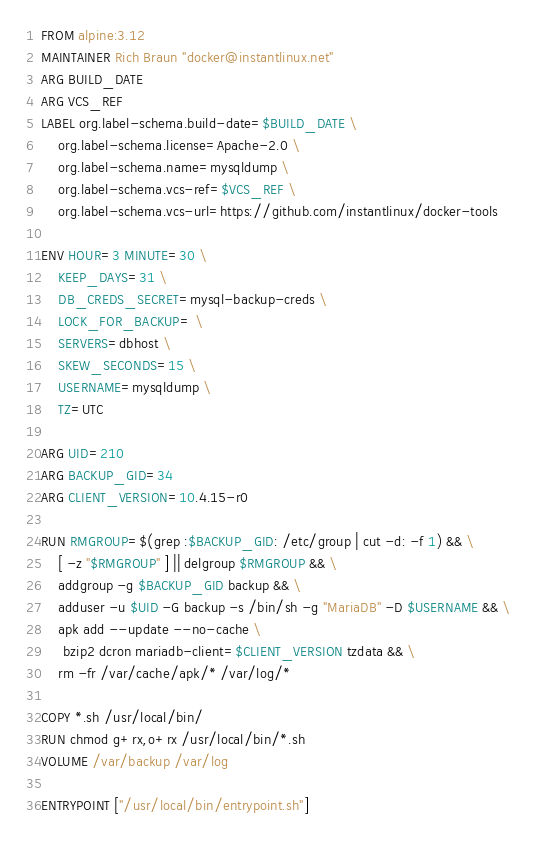<code> <loc_0><loc_0><loc_500><loc_500><_Dockerfile_>FROM alpine:3.12
MAINTAINER Rich Braun "docker@instantlinux.net"
ARG BUILD_DATE
ARG VCS_REF
LABEL org.label-schema.build-date=$BUILD_DATE \
    org.label-schema.license=Apache-2.0 \
    org.label-schema.name=mysqldump \
    org.label-schema.vcs-ref=$VCS_REF \
    org.label-schema.vcs-url=https://github.com/instantlinux/docker-tools

ENV HOUR=3 MINUTE=30 \
    KEEP_DAYS=31 \
    DB_CREDS_SECRET=mysql-backup-creds \
    LOCK_FOR_BACKUP= \
    SERVERS=dbhost \
    SKEW_SECONDS=15 \
    USERNAME=mysqldump \
    TZ=UTC

ARG UID=210
ARG BACKUP_GID=34
ARG CLIENT_VERSION=10.4.15-r0

RUN RMGROUP=$(grep :$BACKUP_GID: /etc/group | cut -d: -f 1) && \
    [ -z "$RMGROUP" ] || delgroup $RMGROUP && \
    addgroup -g $BACKUP_GID backup && \
    adduser -u $UID -G backup -s /bin/sh -g "MariaDB" -D $USERNAME && \
    apk add --update --no-cache \
     bzip2 dcron mariadb-client=$CLIENT_VERSION tzdata && \
    rm -fr /var/cache/apk/* /var/log/*

COPY *.sh /usr/local/bin/
RUN chmod g+rx,o+rx /usr/local/bin/*.sh
VOLUME /var/backup /var/log

ENTRYPOINT ["/usr/local/bin/entrypoint.sh"]
</code> 